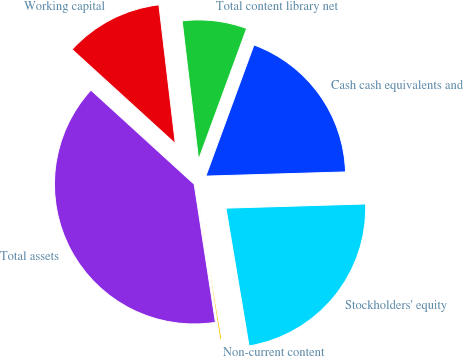Convert chart to OTSL. <chart><loc_0><loc_0><loc_500><loc_500><pie_chart><fcel>Cash cash equivalents and<fcel>Total content library net<fcel>Working capital<fcel>Total assets<fcel>Non-current content<fcel>Stockholders' equity<nl><fcel>18.93%<fcel>7.47%<fcel>11.36%<fcel>39.19%<fcel>0.22%<fcel>22.83%<nl></chart> 